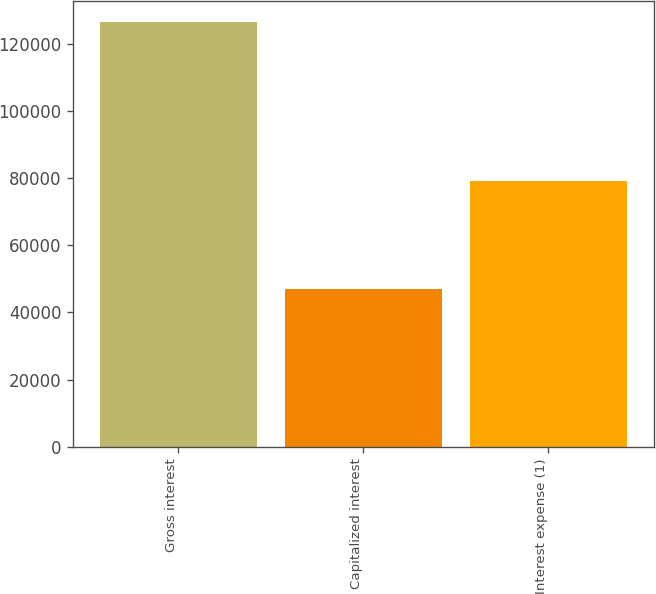Convert chart to OTSL. <chart><loc_0><loc_0><loc_500><loc_500><bar_chart><fcel>Gross interest<fcel>Capitalized interest<fcel>Interest expense (1)<nl><fcel>126404<fcel>47105<fcel>79299<nl></chart> 